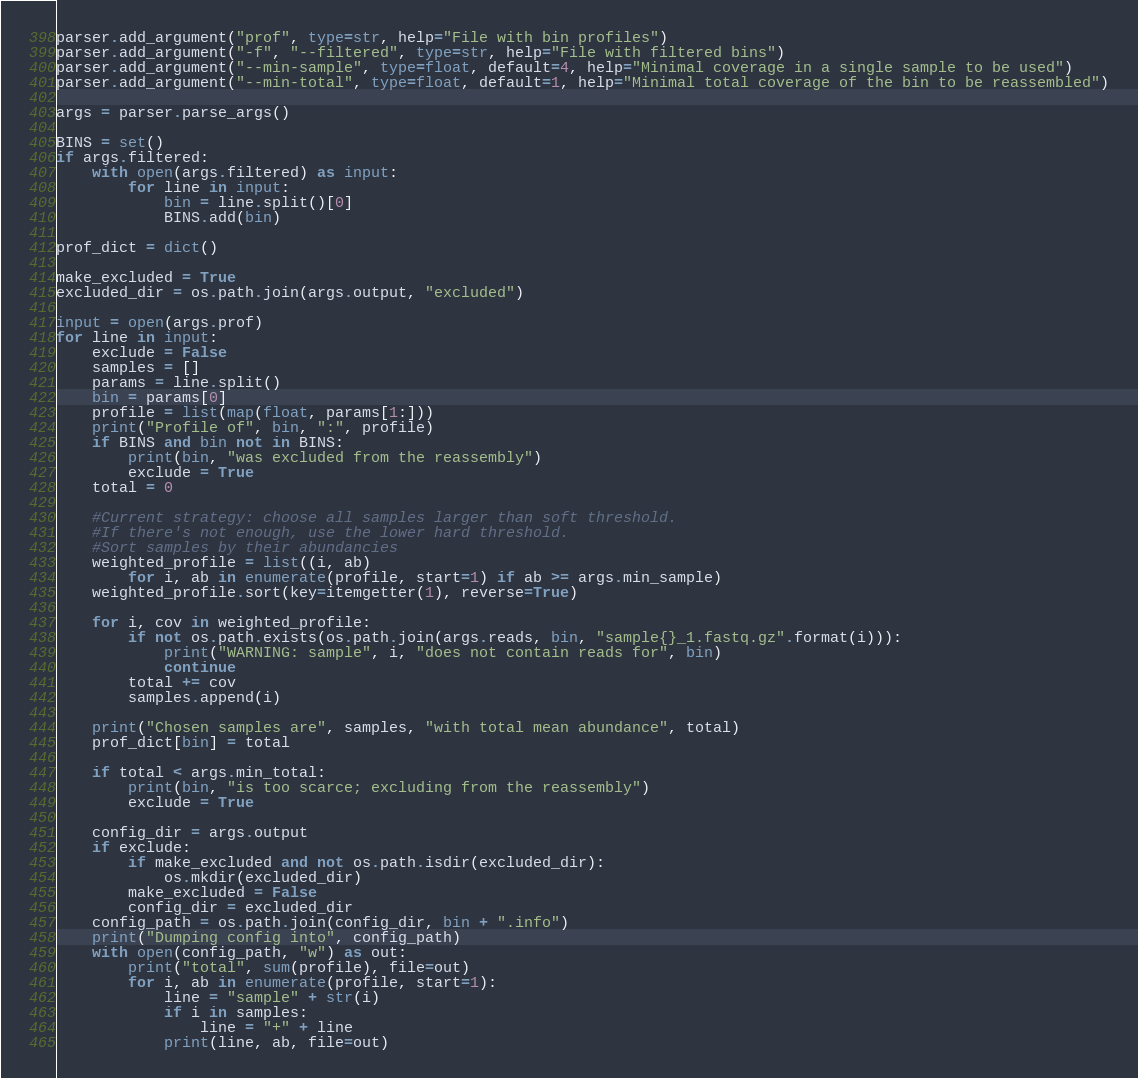<code> <loc_0><loc_0><loc_500><loc_500><_Python_>parser.add_argument("prof", type=str, help="File with bin profiles")
parser.add_argument("-f", "--filtered", type=str, help="File with filtered bins")
parser.add_argument("--min-sample", type=float, default=4, help="Minimal coverage in a single sample to be used")
parser.add_argument("--min-total", type=float, default=1, help="Minimal total coverage of the bin to be reassembled")

args = parser.parse_args()

BINS = set()
if args.filtered:
    with open(args.filtered) as input:
        for line in input:
            bin = line.split()[0]
            BINS.add(bin)

prof_dict = dict()

make_excluded = True
excluded_dir = os.path.join(args.output, "excluded")

input = open(args.prof)
for line in input:
    exclude = False
    samples = []
    params = line.split()
    bin = params[0]
    profile = list(map(float, params[1:]))
    print("Profile of", bin, ":", profile)
    if BINS and bin not in BINS:
        print(bin, "was excluded from the reassembly")
        exclude = True
    total = 0

    #Current strategy: choose all samples larger than soft threshold.
    #If there's not enough, use the lower hard threshold.
    #Sort samples by their abundancies
    weighted_profile = list((i, ab)
        for i, ab in enumerate(profile, start=1) if ab >= args.min_sample)
    weighted_profile.sort(key=itemgetter(1), reverse=True)

    for i, cov in weighted_profile:
        if not os.path.exists(os.path.join(args.reads, bin, "sample{}_1.fastq.gz".format(i))):
            print("WARNING: sample", i, "does not contain reads for", bin)
            continue
        total += cov
        samples.append(i)

    print("Chosen samples are", samples, "with total mean abundance", total)
    prof_dict[bin] = total

    if total < args.min_total:
        print(bin, "is too scarce; excluding from the reassembly")
        exclude = True

    config_dir = args.output
    if exclude:
        if make_excluded and not os.path.isdir(excluded_dir):
            os.mkdir(excluded_dir)
        make_excluded = False
        config_dir = excluded_dir
    config_path = os.path.join(config_dir, bin + ".info")
    print("Dumping config into", config_path)
    with open(config_path, "w") as out:
        print("total", sum(profile), file=out)
        for i, ab in enumerate(profile, start=1):
            line = "sample" + str(i)
            if i in samples:
                line = "+" + line
            print(line, ab, file=out)
</code> 